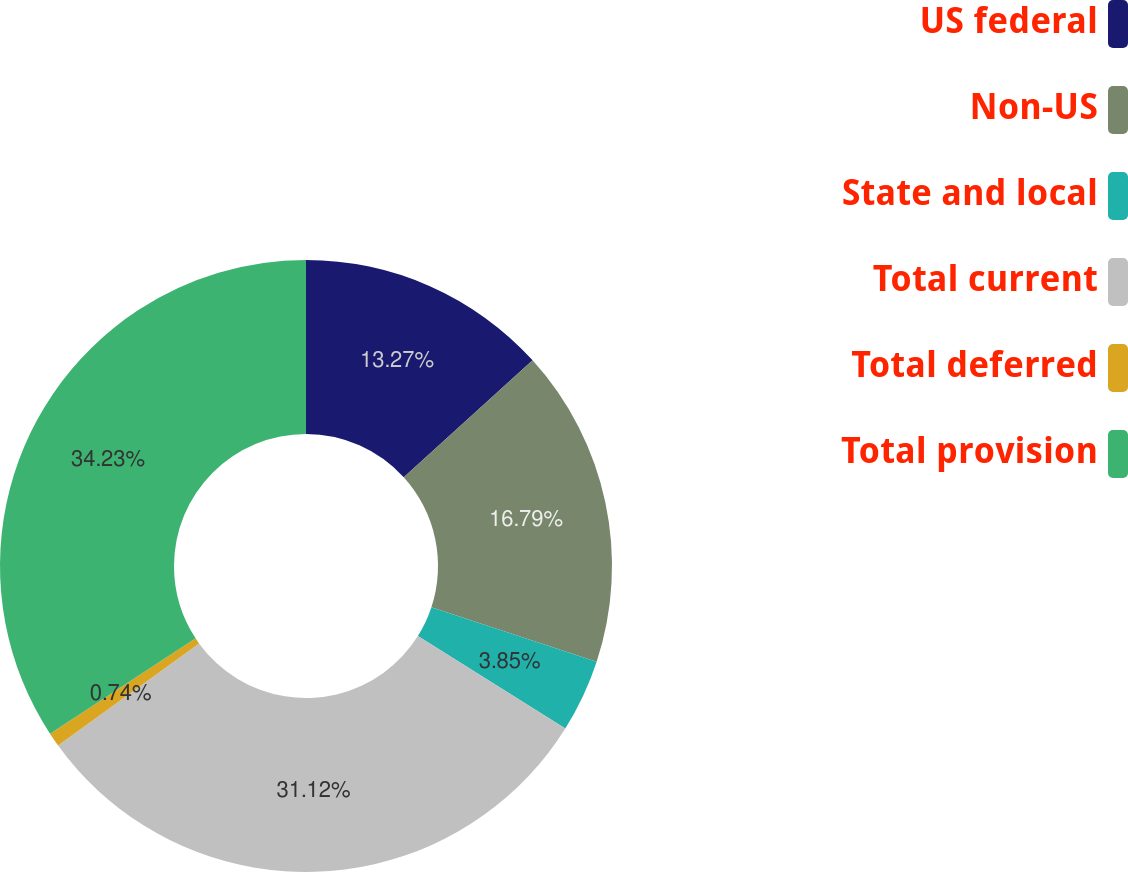Convert chart. <chart><loc_0><loc_0><loc_500><loc_500><pie_chart><fcel>US federal<fcel>Non-US<fcel>State and local<fcel>Total current<fcel>Total deferred<fcel>Total provision<nl><fcel>13.27%<fcel>16.79%<fcel>3.85%<fcel>31.12%<fcel>0.74%<fcel>34.23%<nl></chart> 